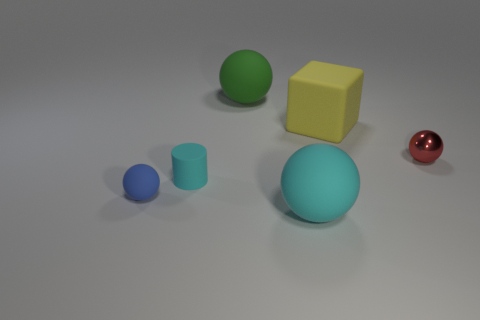How many small cyan spheres are there?
Provide a short and direct response. 0. Does the rubber cube have the same size as the blue rubber object?
Offer a terse response. No. Is there another rubber block of the same color as the big rubber cube?
Keep it short and to the point. No. Do the object to the right of the rubber cube and the small cyan matte object have the same shape?
Offer a terse response. No. What number of brown matte cylinders have the same size as the cyan ball?
Provide a short and direct response. 0. What number of spheres are right of the cyan cylinder on the right side of the blue sphere?
Ensure brevity in your answer.  3. Do the cyan object in front of the blue matte thing and the red sphere have the same material?
Offer a very short reply. No. Is the material of the large ball behind the red object the same as the tiny sphere to the right of the big green sphere?
Provide a succinct answer. No. Is the number of large yellow cubes that are on the right side of the blue ball greater than the number of small red matte blocks?
Make the answer very short. Yes. What is the color of the big ball that is behind the matte object in front of the small blue matte sphere?
Provide a short and direct response. Green. 